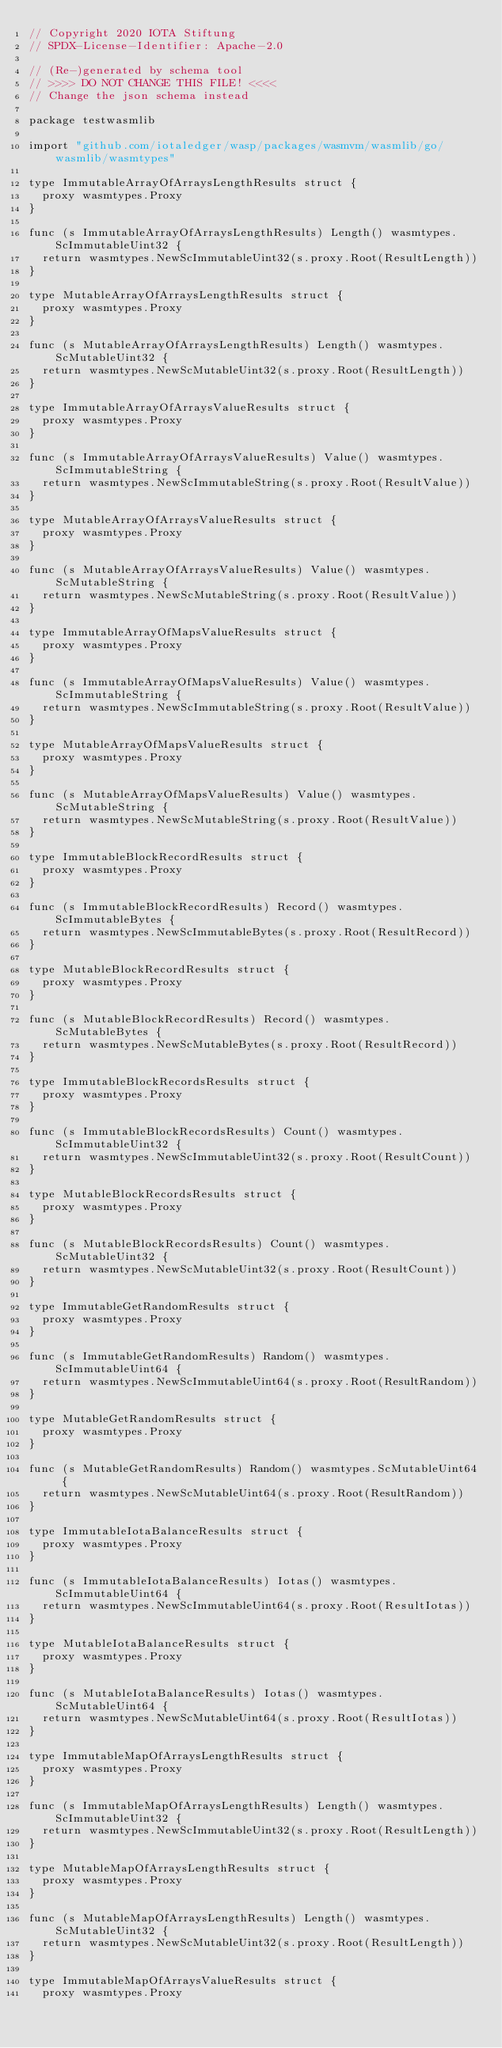<code> <loc_0><loc_0><loc_500><loc_500><_Go_>// Copyright 2020 IOTA Stiftung
// SPDX-License-Identifier: Apache-2.0

// (Re-)generated by schema tool
// >>>> DO NOT CHANGE THIS FILE! <<<<
// Change the json schema instead

package testwasmlib

import "github.com/iotaledger/wasp/packages/wasmvm/wasmlib/go/wasmlib/wasmtypes"

type ImmutableArrayOfArraysLengthResults struct {
	proxy wasmtypes.Proxy
}

func (s ImmutableArrayOfArraysLengthResults) Length() wasmtypes.ScImmutableUint32 {
	return wasmtypes.NewScImmutableUint32(s.proxy.Root(ResultLength))
}

type MutableArrayOfArraysLengthResults struct {
	proxy wasmtypes.Proxy
}

func (s MutableArrayOfArraysLengthResults) Length() wasmtypes.ScMutableUint32 {
	return wasmtypes.NewScMutableUint32(s.proxy.Root(ResultLength))
}

type ImmutableArrayOfArraysValueResults struct {
	proxy wasmtypes.Proxy
}

func (s ImmutableArrayOfArraysValueResults) Value() wasmtypes.ScImmutableString {
	return wasmtypes.NewScImmutableString(s.proxy.Root(ResultValue))
}

type MutableArrayOfArraysValueResults struct {
	proxy wasmtypes.Proxy
}

func (s MutableArrayOfArraysValueResults) Value() wasmtypes.ScMutableString {
	return wasmtypes.NewScMutableString(s.proxy.Root(ResultValue))
}

type ImmutableArrayOfMapsValueResults struct {
	proxy wasmtypes.Proxy
}

func (s ImmutableArrayOfMapsValueResults) Value() wasmtypes.ScImmutableString {
	return wasmtypes.NewScImmutableString(s.proxy.Root(ResultValue))
}

type MutableArrayOfMapsValueResults struct {
	proxy wasmtypes.Proxy
}

func (s MutableArrayOfMapsValueResults) Value() wasmtypes.ScMutableString {
	return wasmtypes.NewScMutableString(s.proxy.Root(ResultValue))
}

type ImmutableBlockRecordResults struct {
	proxy wasmtypes.Proxy
}

func (s ImmutableBlockRecordResults) Record() wasmtypes.ScImmutableBytes {
	return wasmtypes.NewScImmutableBytes(s.proxy.Root(ResultRecord))
}

type MutableBlockRecordResults struct {
	proxy wasmtypes.Proxy
}

func (s MutableBlockRecordResults) Record() wasmtypes.ScMutableBytes {
	return wasmtypes.NewScMutableBytes(s.proxy.Root(ResultRecord))
}

type ImmutableBlockRecordsResults struct {
	proxy wasmtypes.Proxy
}

func (s ImmutableBlockRecordsResults) Count() wasmtypes.ScImmutableUint32 {
	return wasmtypes.NewScImmutableUint32(s.proxy.Root(ResultCount))
}

type MutableBlockRecordsResults struct {
	proxy wasmtypes.Proxy
}

func (s MutableBlockRecordsResults) Count() wasmtypes.ScMutableUint32 {
	return wasmtypes.NewScMutableUint32(s.proxy.Root(ResultCount))
}

type ImmutableGetRandomResults struct {
	proxy wasmtypes.Proxy
}

func (s ImmutableGetRandomResults) Random() wasmtypes.ScImmutableUint64 {
	return wasmtypes.NewScImmutableUint64(s.proxy.Root(ResultRandom))
}

type MutableGetRandomResults struct {
	proxy wasmtypes.Proxy
}

func (s MutableGetRandomResults) Random() wasmtypes.ScMutableUint64 {
	return wasmtypes.NewScMutableUint64(s.proxy.Root(ResultRandom))
}

type ImmutableIotaBalanceResults struct {
	proxy wasmtypes.Proxy
}

func (s ImmutableIotaBalanceResults) Iotas() wasmtypes.ScImmutableUint64 {
	return wasmtypes.NewScImmutableUint64(s.proxy.Root(ResultIotas))
}

type MutableIotaBalanceResults struct {
	proxy wasmtypes.Proxy
}

func (s MutableIotaBalanceResults) Iotas() wasmtypes.ScMutableUint64 {
	return wasmtypes.NewScMutableUint64(s.proxy.Root(ResultIotas))
}

type ImmutableMapOfArraysLengthResults struct {
	proxy wasmtypes.Proxy
}

func (s ImmutableMapOfArraysLengthResults) Length() wasmtypes.ScImmutableUint32 {
	return wasmtypes.NewScImmutableUint32(s.proxy.Root(ResultLength))
}

type MutableMapOfArraysLengthResults struct {
	proxy wasmtypes.Proxy
}

func (s MutableMapOfArraysLengthResults) Length() wasmtypes.ScMutableUint32 {
	return wasmtypes.NewScMutableUint32(s.proxy.Root(ResultLength))
}

type ImmutableMapOfArraysValueResults struct {
	proxy wasmtypes.Proxy</code> 